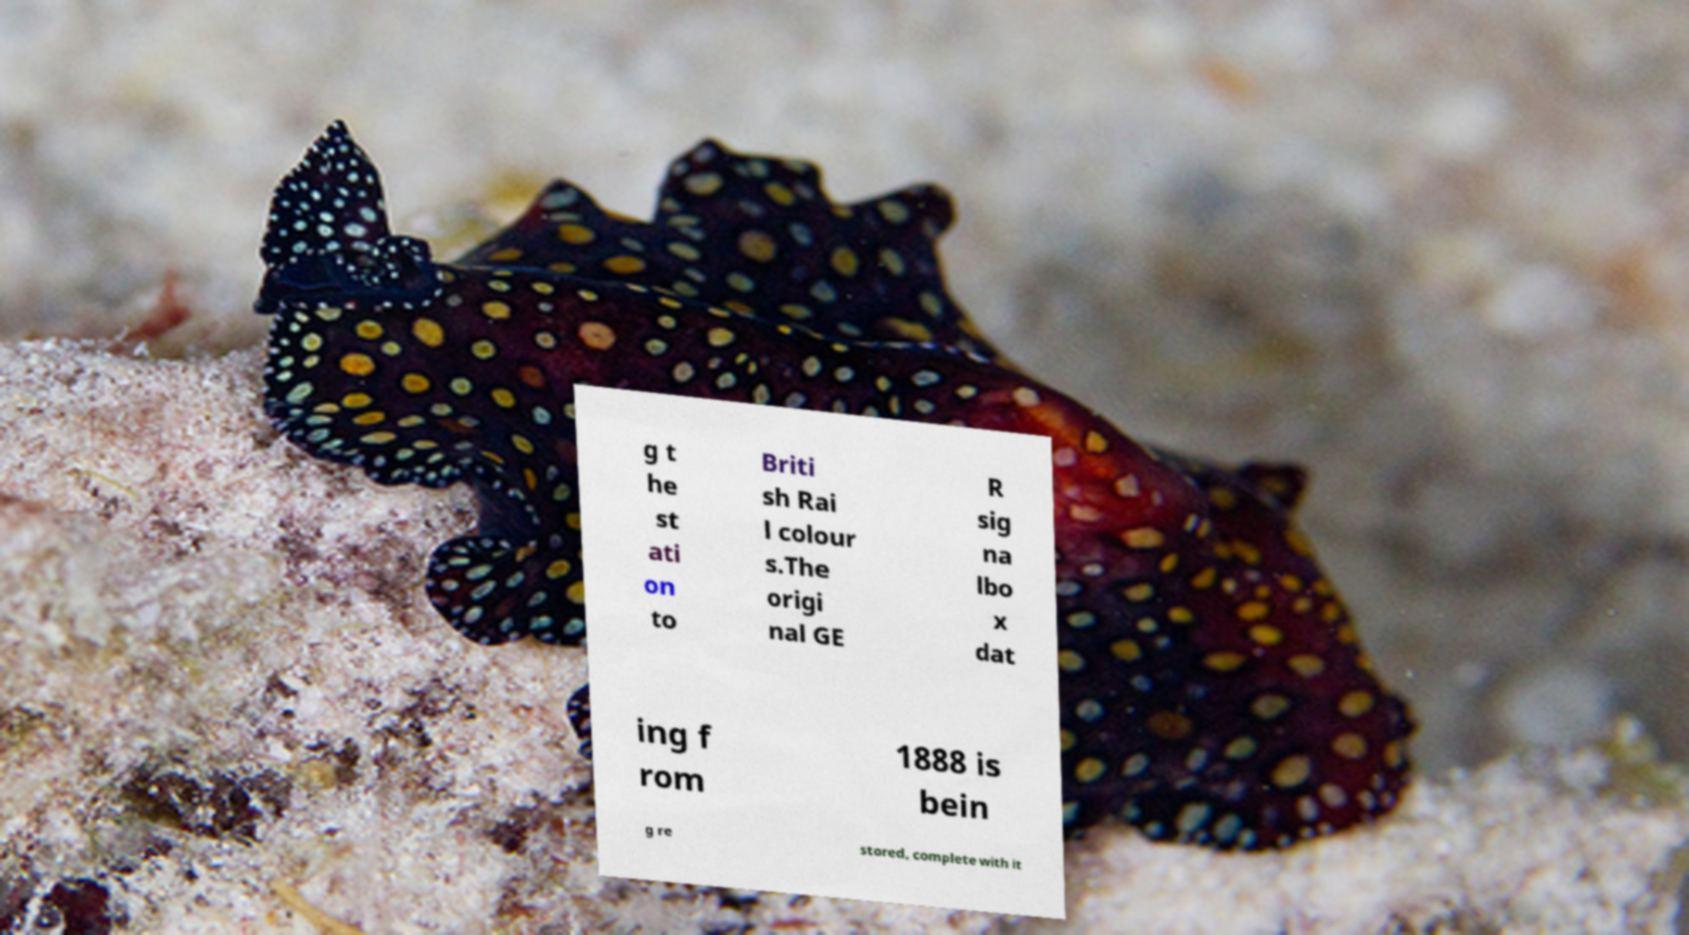For documentation purposes, I need the text within this image transcribed. Could you provide that? g t he st ati on to Briti sh Rai l colour s.The origi nal GE R sig na lbo x dat ing f rom 1888 is bein g re stored, complete with it 